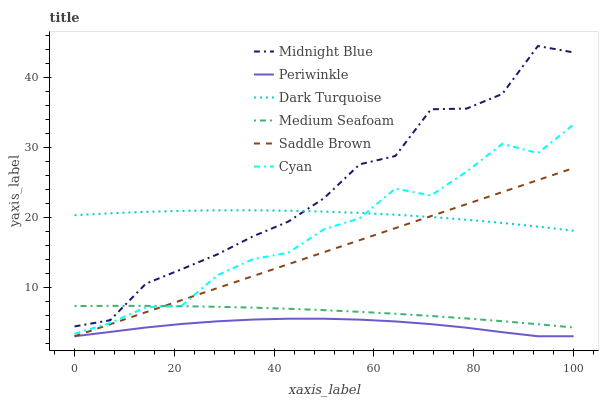Does Periwinkle have the minimum area under the curve?
Answer yes or no. Yes. Does Midnight Blue have the maximum area under the curve?
Answer yes or no. Yes. Does Dark Turquoise have the minimum area under the curve?
Answer yes or no. No. Does Dark Turquoise have the maximum area under the curve?
Answer yes or no. No. Is Saddle Brown the smoothest?
Answer yes or no. Yes. Is Midnight Blue the roughest?
Answer yes or no. Yes. Is Dark Turquoise the smoothest?
Answer yes or no. No. Is Dark Turquoise the roughest?
Answer yes or no. No. Does Periwinkle have the lowest value?
Answer yes or no. Yes. Does Medium Seafoam have the lowest value?
Answer yes or no. No. Does Midnight Blue have the highest value?
Answer yes or no. Yes. Does Dark Turquoise have the highest value?
Answer yes or no. No. Is Periwinkle less than Medium Seafoam?
Answer yes or no. Yes. Is Dark Turquoise greater than Periwinkle?
Answer yes or no. Yes. Does Saddle Brown intersect Dark Turquoise?
Answer yes or no. Yes. Is Saddle Brown less than Dark Turquoise?
Answer yes or no. No. Is Saddle Brown greater than Dark Turquoise?
Answer yes or no. No. Does Periwinkle intersect Medium Seafoam?
Answer yes or no. No. 